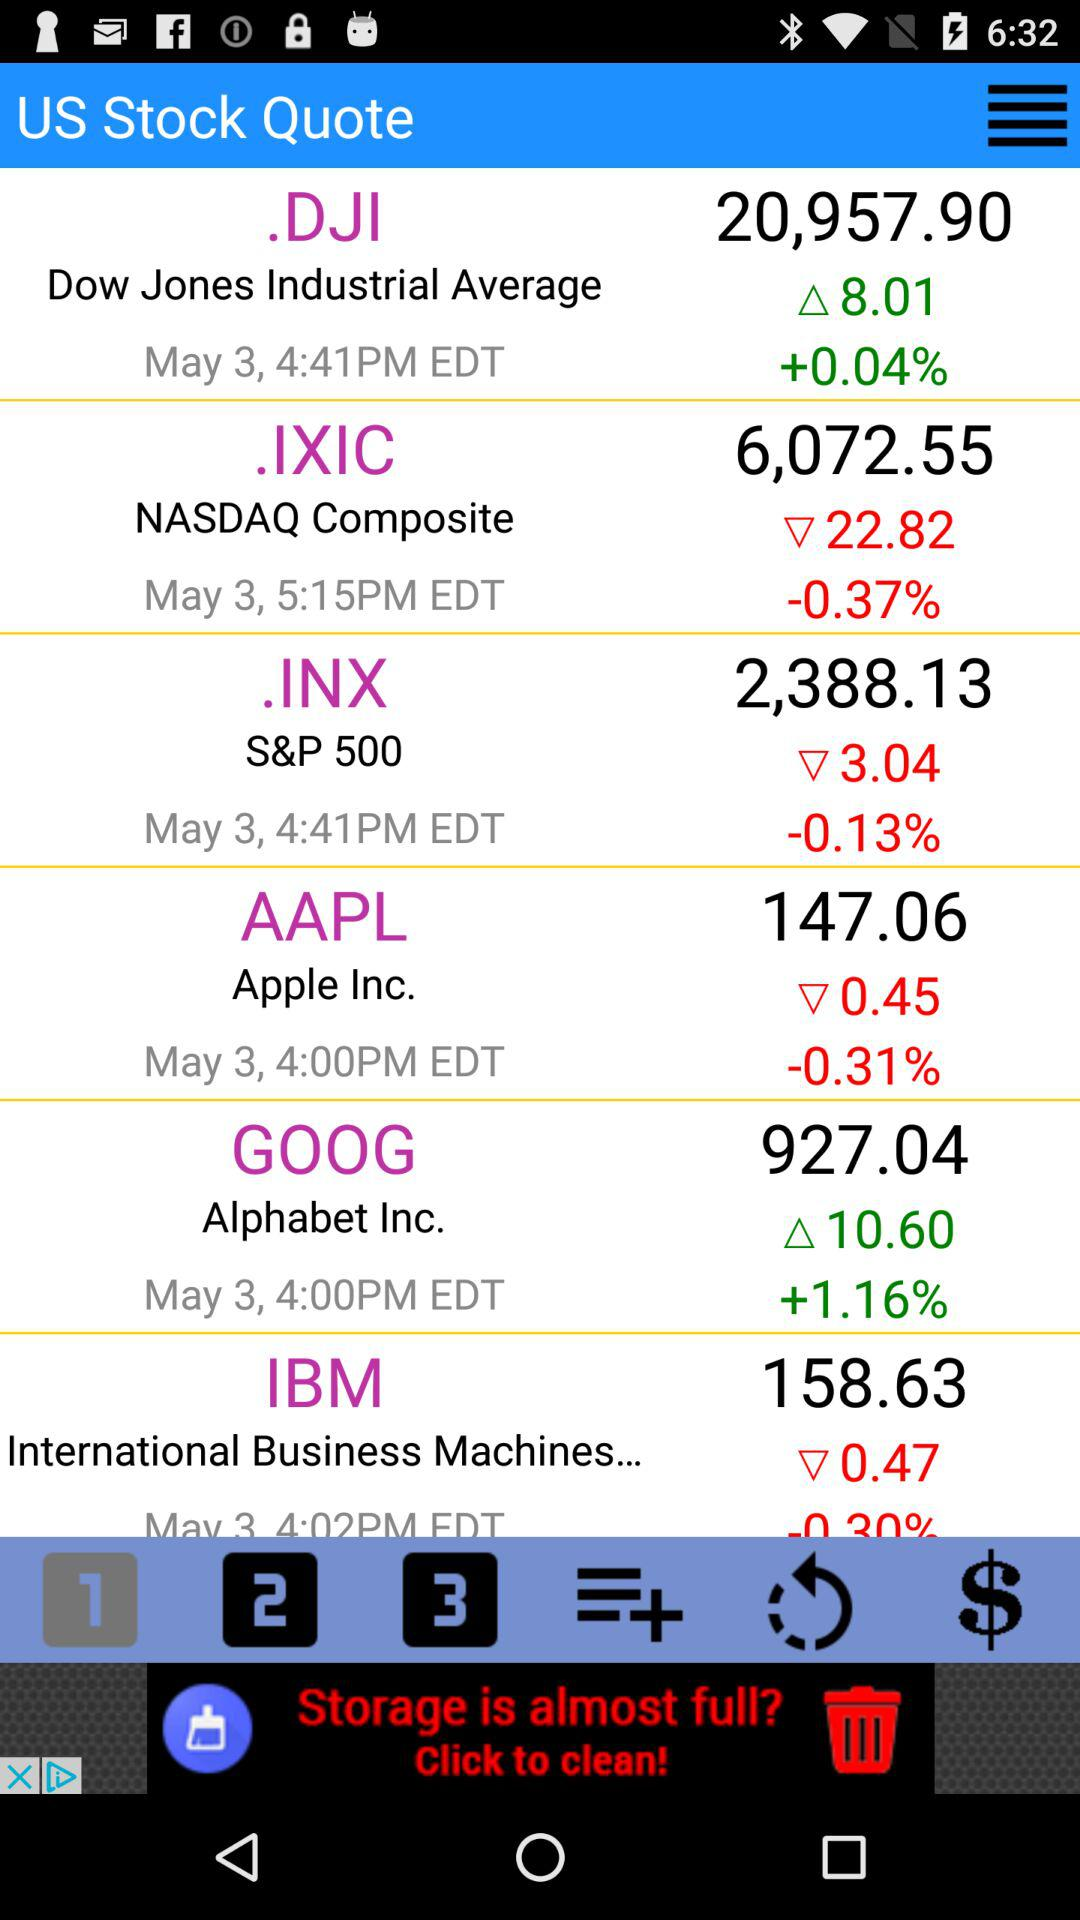What is the stock price of the NASDAQ composite? The stock price of the NASDAQ composite is 6,072.55. 